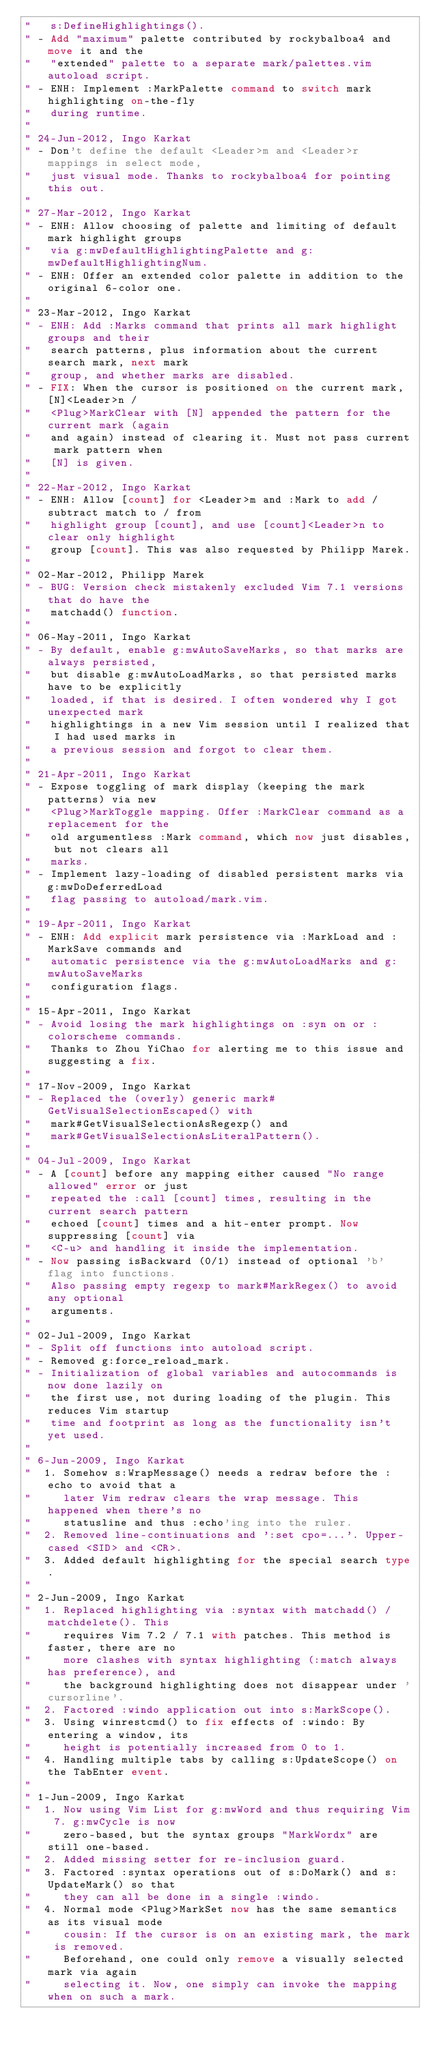<code> <loc_0><loc_0><loc_500><loc_500><_VisualBasic_>"   s:DefineHighlightings().
" - Add "maximum" palette contributed by rockybalboa4 and move it and the
"   "extended" palette to a separate mark/palettes.vim autoload script.
" - ENH: Implement :MarkPalette command to switch mark highlighting on-the-fly
"   during runtime.
"
" 24-Jun-2012, Ingo Karkat
" - Don't define the default <Leader>m and <Leader>r mappings in select mode,
"   just visual mode. Thanks to rockybalboa4 for pointing this out.
"
" 27-Mar-2012, Ingo Karkat
" - ENH: Allow choosing of palette and limiting of default mark highlight groups
"   via g:mwDefaultHighlightingPalette and g:mwDefaultHighlightingNum.
" - ENH: Offer an extended color palette in addition to the original 6-color one.
"
" 23-Mar-2012, Ingo Karkat
" - ENH: Add :Marks command that prints all mark highlight groups and their
"   search patterns, plus information about the current search mark, next mark
"   group, and whether marks are disabled.
" - FIX: When the cursor is positioned on the current mark, [N]<Leader>n /
"   <Plug>MarkClear with [N] appended the pattern for the current mark (again
"   and again) instead of clearing it. Must not pass current mark pattern when
"   [N] is given.
"
" 22-Mar-2012, Ingo Karkat
" - ENH: Allow [count] for <Leader>m and :Mark to add / subtract match to / from
"   highlight group [count], and use [count]<Leader>n to clear only highlight
"   group [count]. This was also requested by Philipp Marek.
"
" 02-Mar-2012, Philipp Marek
" - BUG: Version check mistakenly excluded Vim 7.1 versions that do have the
"   matchadd() function.
"
" 06-May-2011, Ingo Karkat
" - By default, enable g:mwAutoSaveMarks, so that marks are always persisted,
"   but disable g:mwAutoLoadMarks, so that persisted marks have to be explicitly
"   loaded, if that is desired. I often wondered why I got unexpected mark
"   highlightings in a new Vim session until I realized that I had used marks in
"   a previous session and forgot to clear them.
"
" 21-Apr-2011, Ingo Karkat
" - Expose toggling of mark display (keeping the mark patterns) via new
"   <Plug>MarkToggle mapping. Offer :MarkClear command as a replacement for the
"   old argumentless :Mark command, which now just disables, but not clears all
"   marks.
" - Implement lazy-loading of disabled persistent marks via g:mwDoDeferredLoad
"   flag passing to autoload/mark.vim.
"
" 19-Apr-2011, Ingo Karkat
" - ENH: Add explicit mark persistence via :MarkLoad and :MarkSave commands and
"   automatic persistence via the g:mwAutoLoadMarks and g:mwAutoSaveMarks
"   configuration flags.
"
" 15-Apr-2011, Ingo Karkat
" - Avoid losing the mark highlightings on :syn on or :colorscheme commands.
"   Thanks to Zhou YiChao for alerting me to this issue and suggesting a fix.
"
" 17-Nov-2009, Ingo Karkat
" - Replaced the (overly) generic mark#GetVisualSelectionEscaped() with
"   mark#GetVisualSelectionAsRegexp() and
"   mark#GetVisualSelectionAsLiteralPattern().
"
" 04-Jul-2009, Ingo Karkat
" - A [count] before any mapping either caused "No range allowed" error or just
"   repeated the :call [count] times, resulting in the current search pattern
"   echoed [count] times and a hit-enter prompt. Now suppressing [count] via
"   <C-u> and handling it inside the implementation.
" - Now passing isBackward (0/1) instead of optional 'b' flag into functions.
"   Also passing empty regexp to mark#MarkRegex() to avoid any optional
"   arguments.
"
" 02-Jul-2009, Ingo Karkat
" - Split off functions into autoload script.
" - Removed g:force_reload_mark.
" - Initialization of global variables and autocommands is now done lazily on
"   the first use, not during loading of the plugin. This reduces Vim startup
"   time and footprint as long as the functionality isn't yet used.
"
" 6-Jun-2009, Ingo Karkat
"  1. Somehow s:WrapMessage() needs a redraw before the :echo to avoid that a
"     later Vim redraw clears the wrap message. This happened when there's no
"     statusline and thus :echo'ing into the ruler.
"  2. Removed line-continuations and ':set cpo=...'. Upper-cased <SID> and <CR>.
"  3. Added default highlighting for the special search type.
"
" 2-Jun-2009, Ingo Karkat
"  1. Replaced highlighting via :syntax with matchadd() / matchdelete(). This
"     requires Vim 7.2 / 7.1 with patches. This method is faster, there are no
"     more clashes with syntax highlighting (:match always has preference), and
"     the background highlighting does not disappear under 'cursorline'.
"  2. Factored :windo application out into s:MarkScope().
"  3. Using winrestcmd() to fix effects of :windo: By entering a window, its
"     height is potentially increased from 0 to 1.
"  4. Handling multiple tabs by calling s:UpdateScope() on the TabEnter event.
"
" 1-Jun-2009, Ingo Karkat
"  1. Now using Vim List for g:mwWord and thus requiring Vim 7. g:mwCycle is now
"     zero-based, but the syntax groups "MarkWordx" are still one-based.
"  2. Added missing setter for re-inclusion guard.
"  3. Factored :syntax operations out of s:DoMark() and s:UpdateMark() so that
"     they can all be done in a single :windo.
"  4. Normal mode <Plug>MarkSet now has the same semantics as its visual mode
"     cousin: If the cursor is on an existing mark, the mark is removed.
"     Beforehand, one could only remove a visually selected mark via again
"     selecting it. Now, one simply can invoke the mapping when on such a mark.</code> 